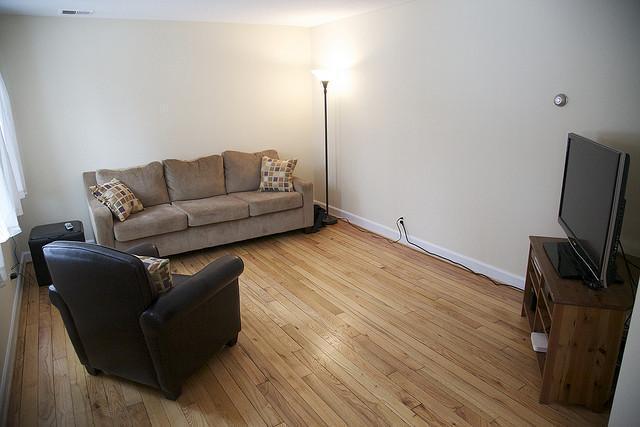How many tvs are there?
Give a very brief answer. 1. 